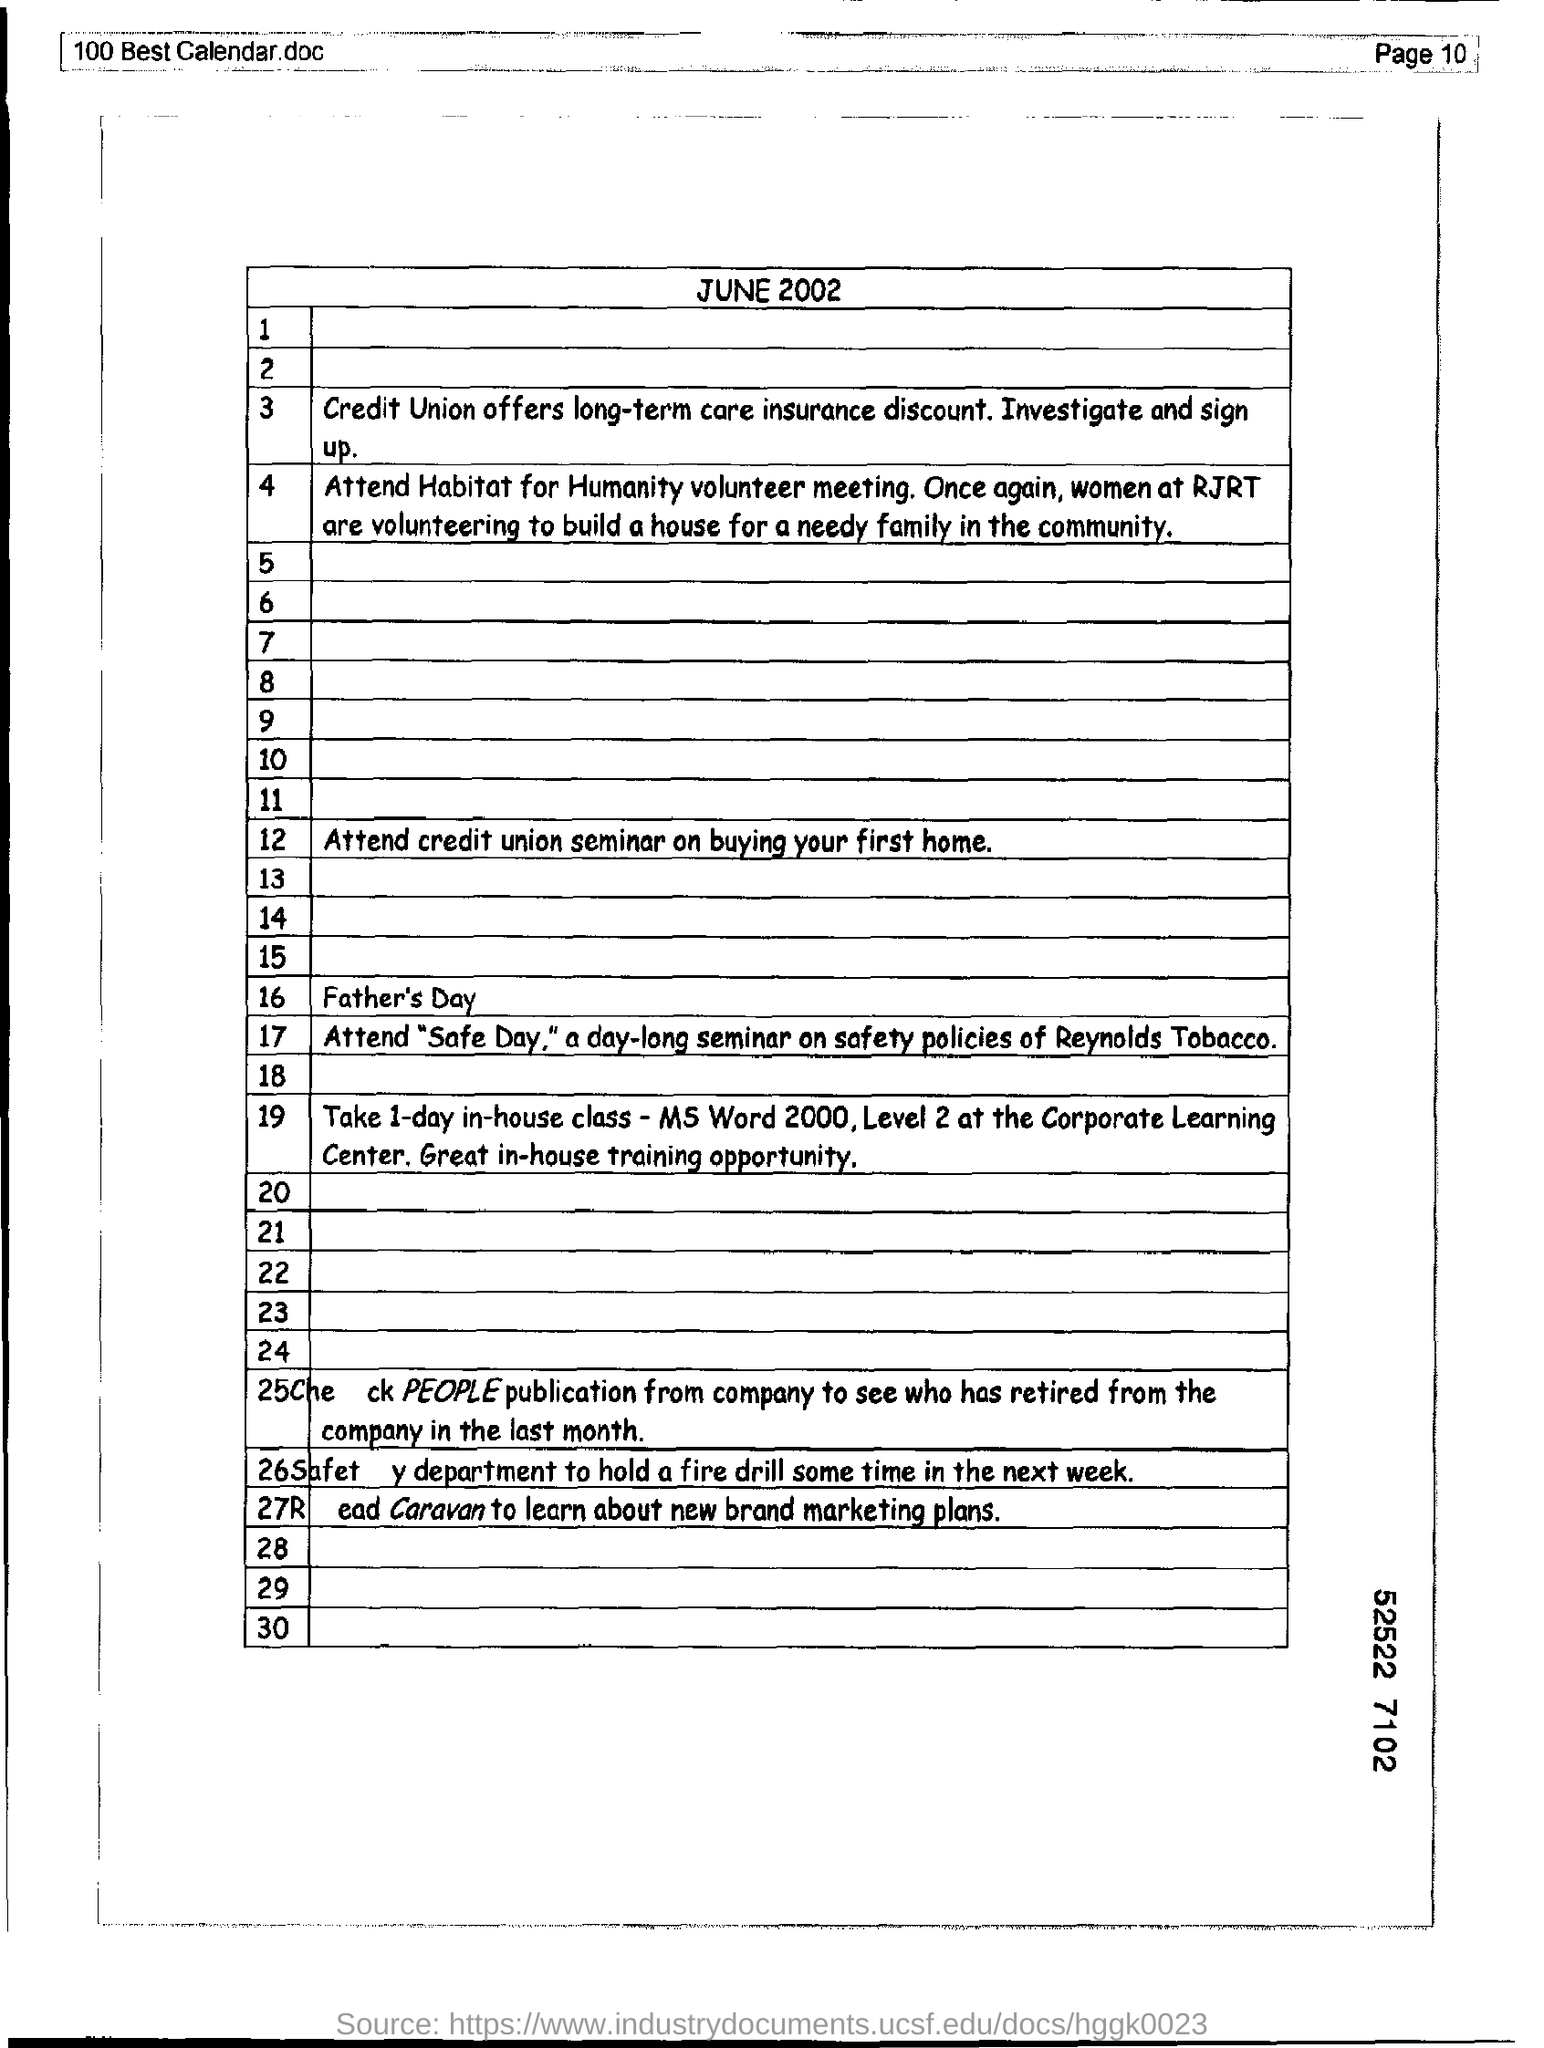List a handful of essential elements in this visual. Credit unions offer long-term care insurance discounts. The document mentions that the date is June 2002. 